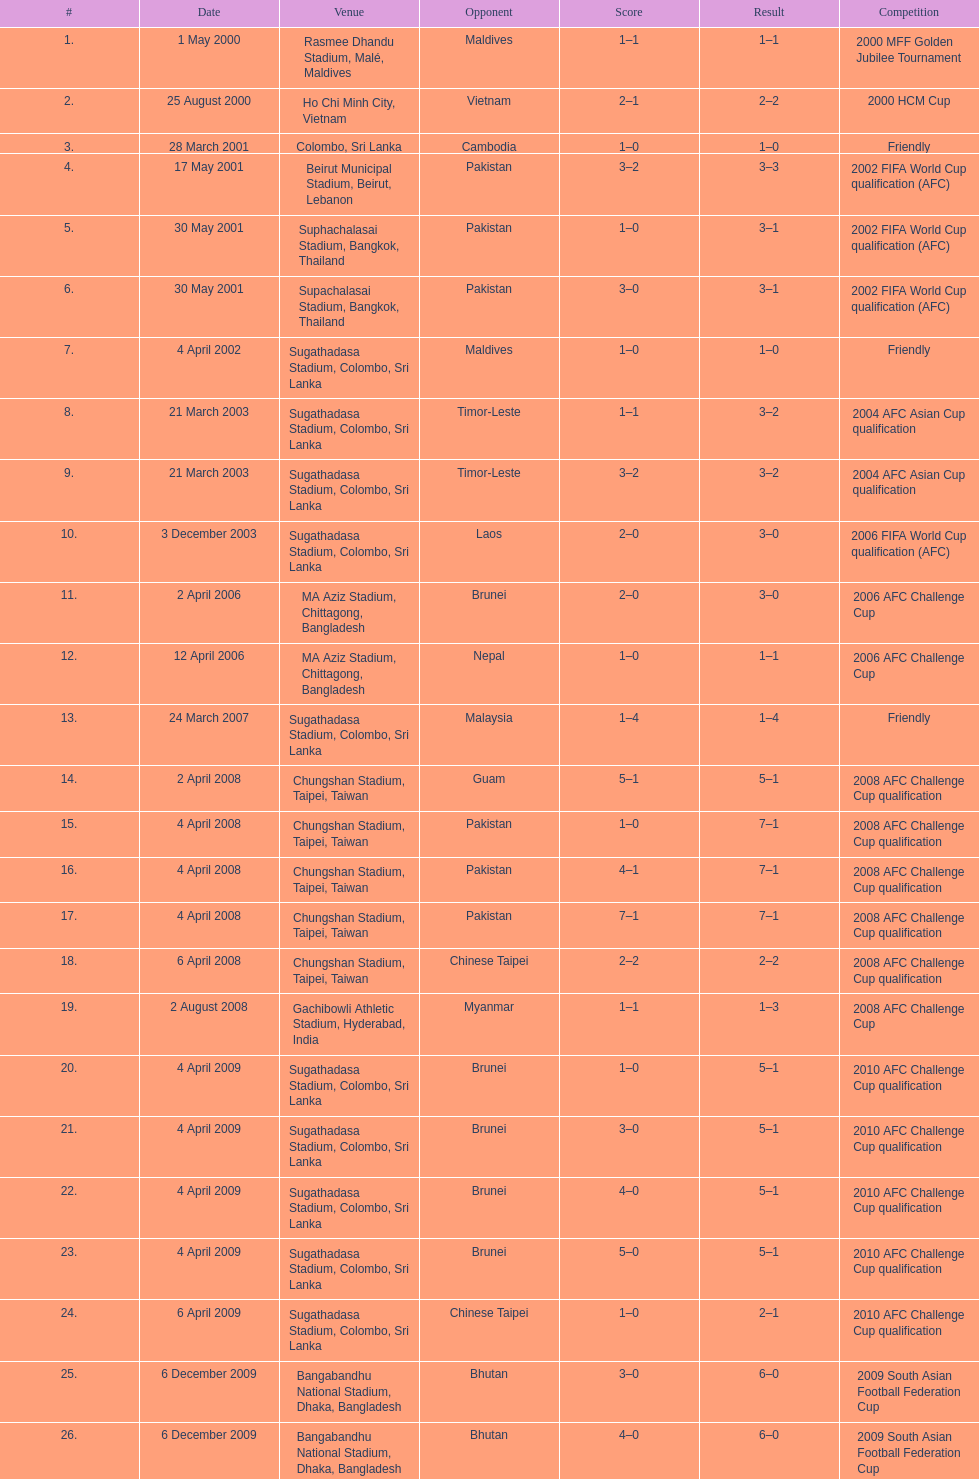In how many matches did sri lanka achieve a minimum of 2 goals? 16. Give me the full table as a dictionary. {'header': ['#', 'Date', 'Venue', 'Opponent', 'Score', 'Result', 'Competition'], 'rows': [['1.', '1 May 2000', 'Rasmee Dhandu Stadium, Malé, Maldives', 'Maldives', '1–1', '1–1', '2000 MFF Golden Jubilee Tournament'], ['2.', '25 August 2000', 'Ho Chi Minh City, Vietnam', 'Vietnam', '2–1', '2–2', '2000 HCM Cup'], ['3.', '28 March 2001', 'Colombo, Sri Lanka', 'Cambodia', '1–0', '1–0', 'Friendly'], ['4.', '17 May 2001', 'Beirut Municipal Stadium, Beirut, Lebanon', 'Pakistan', '3–2', '3–3', '2002 FIFA World Cup qualification (AFC)'], ['5.', '30 May 2001', 'Suphachalasai Stadium, Bangkok, Thailand', 'Pakistan', '1–0', '3–1', '2002 FIFA World Cup qualification (AFC)'], ['6.', '30 May 2001', 'Supachalasai Stadium, Bangkok, Thailand', 'Pakistan', '3–0', '3–1', '2002 FIFA World Cup qualification (AFC)'], ['7.', '4 April 2002', 'Sugathadasa Stadium, Colombo, Sri Lanka', 'Maldives', '1–0', '1–0', 'Friendly'], ['8.', '21 March 2003', 'Sugathadasa Stadium, Colombo, Sri Lanka', 'Timor-Leste', '1–1', '3–2', '2004 AFC Asian Cup qualification'], ['9.', '21 March 2003', 'Sugathadasa Stadium, Colombo, Sri Lanka', 'Timor-Leste', '3–2', '3–2', '2004 AFC Asian Cup qualification'], ['10.', '3 December 2003', 'Sugathadasa Stadium, Colombo, Sri Lanka', 'Laos', '2–0', '3–0', '2006 FIFA World Cup qualification (AFC)'], ['11.', '2 April 2006', 'MA Aziz Stadium, Chittagong, Bangladesh', 'Brunei', '2–0', '3–0', '2006 AFC Challenge Cup'], ['12.', '12 April 2006', 'MA Aziz Stadium, Chittagong, Bangladesh', 'Nepal', '1–0', '1–1', '2006 AFC Challenge Cup'], ['13.', '24 March 2007', 'Sugathadasa Stadium, Colombo, Sri Lanka', 'Malaysia', '1–4', '1–4', 'Friendly'], ['14.', '2 April 2008', 'Chungshan Stadium, Taipei, Taiwan', 'Guam', '5–1', '5–1', '2008 AFC Challenge Cup qualification'], ['15.', '4 April 2008', 'Chungshan Stadium, Taipei, Taiwan', 'Pakistan', '1–0', '7–1', '2008 AFC Challenge Cup qualification'], ['16.', '4 April 2008', 'Chungshan Stadium, Taipei, Taiwan', 'Pakistan', '4–1', '7–1', '2008 AFC Challenge Cup qualification'], ['17.', '4 April 2008', 'Chungshan Stadium, Taipei, Taiwan', 'Pakistan', '7–1', '7–1', '2008 AFC Challenge Cup qualification'], ['18.', '6 April 2008', 'Chungshan Stadium, Taipei, Taiwan', 'Chinese Taipei', '2–2', '2–2', '2008 AFC Challenge Cup qualification'], ['19.', '2 August 2008', 'Gachibowli Athletic Stadium, Hyderabad, India', 'Myanmar', '1–1', '1–3', '2008 AFC Challenge Cup'], ['20.', '4 April 2009', 'Sugathadasa Stadium, Colombo, Sri Lanka', 'Brunei', '1–0', '5–1', '2010 AFC Challenge Cup qualification'], ['21.', '4 April 2009', 'Sugathadasa Stadium, Colombo, Sri Lanka', 'Brunei', '3–0', '5–1', '2010 AFC Challenge Cup qualification'], ['22.', '4 April 2009', 'Sugathadasa Stadium, Colombo, Sri Lanka', 'Brunei', '4–0', '5–1', '2010 AFC Challenge Cup qualification'], ['23.', '4 April 2009', 'Sugathadasa Stadium, Colombo, Sri Lanka', 'Brunei', '5–0', '5–1', '2010 AFC Challenge Cup qualification'], ['24.', '6 April 2009', 'Sugathadasa Stadium, Colombo, Sri Lanka', 'Chinese Taipei', '1–0', '2–1', '2010 AFC Challenge Cup qualification'], ['25.', '6 December 2009', 'Bangabandhu National Stadium, Dhaka, Bangladesh', 'Bhutan', '3–0', '6–0', '2009 South Asian Football Federation Cup'], ['26.', '6 December 2009', 'Bangabandhu National Stadium, Dhaka, Bangladesh', 'Bhutan', '4–0', '6–0', '2009 South Asian Football Federation Cup'], ['27.', '6 December 2009', 'Bangabandhu National Stadium, Dhaka, Bangladesh', 'Bhutan', '5–0', '6–0', '2009 South Asian Football Federation Cup']]} 